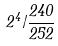Convert formula to latex. <formula><loc_0><loc_0><loc_500><loc_500>2 ^ { 4 } / \frac { 2 4 0 } { 2 5 2 }</formula> 